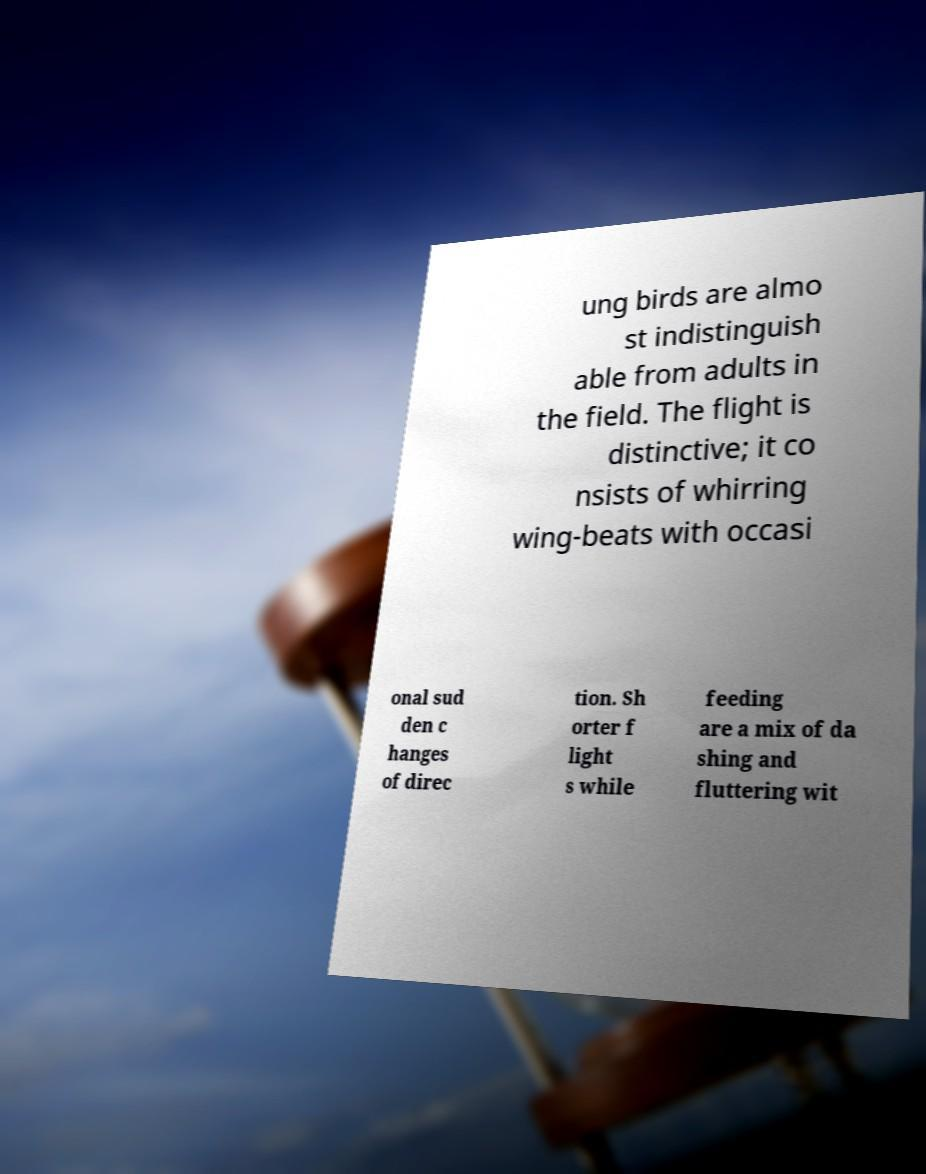I need the written content from this picture converted into text. Can you do that? ung birds are almo st indistinguish able from adults in the field. The flight is distinctive; it co nsists of whirring wing-beats with occasi onal sud den c hanges of direc tion. Sh orter f light s while feeding are a mix of da shing and fluttering wit 